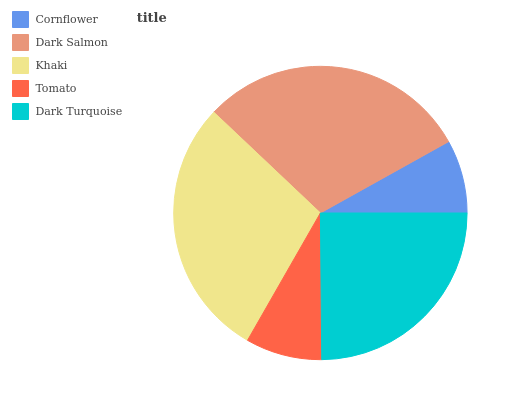Is Cornflower the minimum?
Answer yes or no. Yes. Is Dark Salmon the maximum?
Answer yes or no. Yes. Is Khaki the minimum?
Answer yes or no. No. Is Khaki the maximum?
Answer yes or no. No. Is Dark Salmon greater than Khaki?
Answer yes or no. Yes. Is Khaki less than Dark Salmon?
Answer yes or no. Yes. Is Khaki greater than Dark Salmon?
Answer yes or no. No. Is Dark Salmon less than Khaki?
Answer yes or no. No. Is Dark Turquoise the high median?
Answer yes or no. Yes. Is Dark Turquoise the low median?
Answer yes or no. Yes. Is Cornflower the high median?
Answer yes or no. No. Is Cornflower the low median?
Answer yes or no. No. 